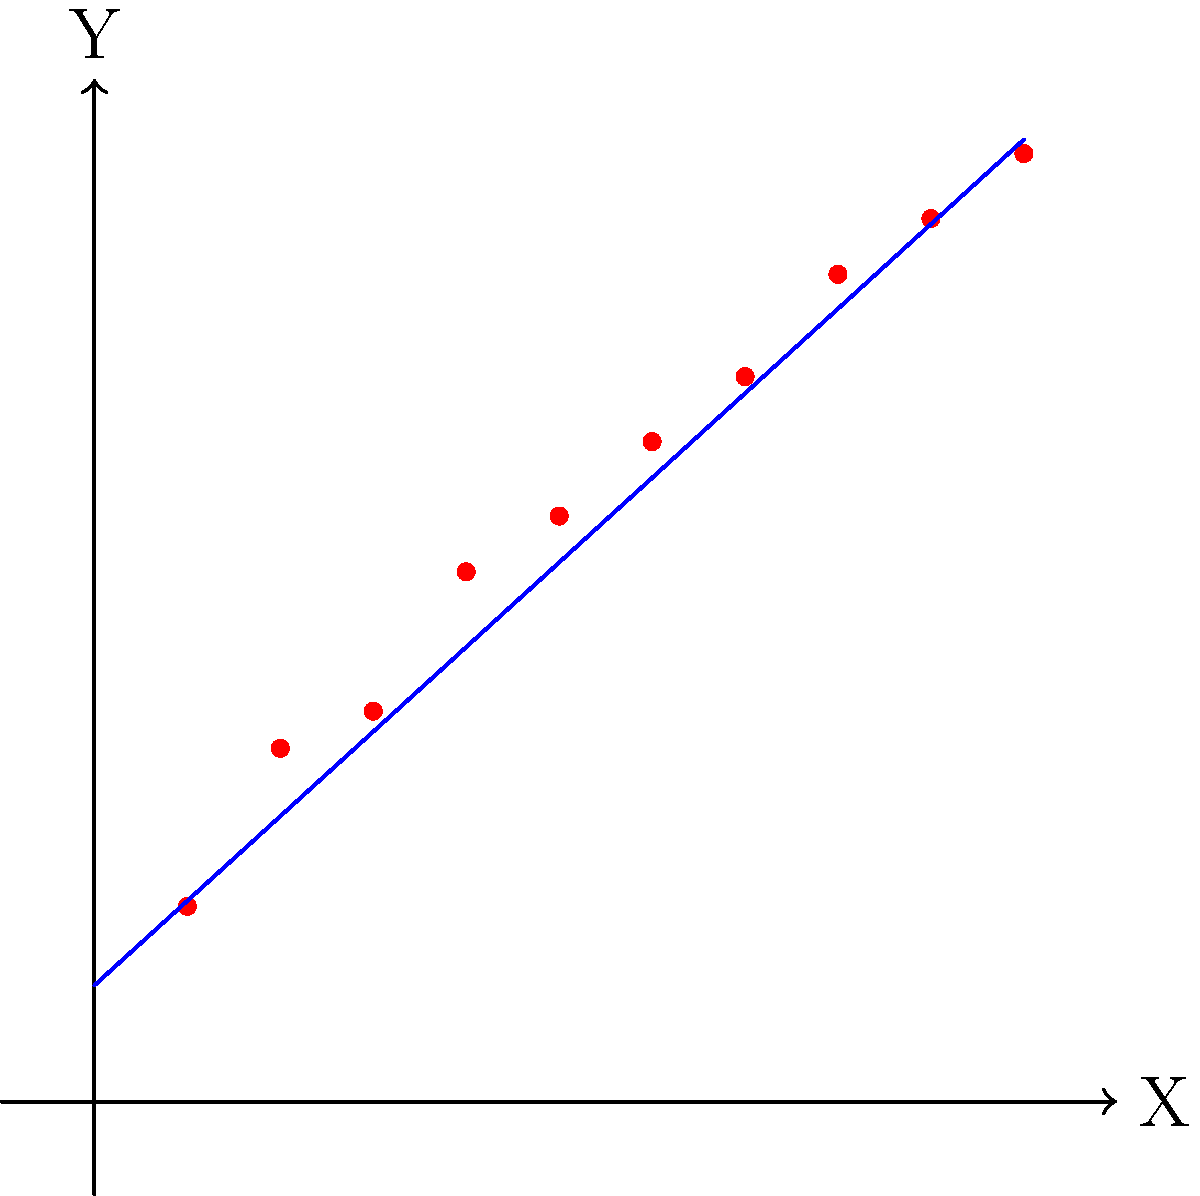In a large-scale study, researchers collected data on two variables, X and Y, from 1000 participants. The scatter plot above shows a representative sample of 10 data points from this study, along with a best-fit line. Based on your analysis of this scatter plot, what can you infer about the correlation between X and Y in the full dataset? Provide your reasoning and discuss any limitations of this inference. To analyze the correlation between X and Y based on the given scatter plot, we can follow these steps:

1. Visual inspection:
   The points appear to follow a clear upward trend from left to right, suggesting a positive correlation.

2. Strength of relationship:
   The points are relatively close to the best-fit line, indicating a strong relationship.

3. Linearity:
   The relationship appears to be approximately linear, as the points don't show any obvious curved pattern.

4. Slope of best-fit line:
   The best-fit line has a positive slope, confirming the positive correlation.

5. Quantitative assessment:
   We can roughly estimate the correlation coefficient (r) to be between 0.8 and 0.95, indicating a strong positive correlation.

6. Inference to full dataset:
   Given that this is a representative sample, we can infer that the full dataset of 1000 participants likely shows a strong positive correlation between X and Y.

7. Limitations:
   a) Sample size: We're basing our inference on only 10 data points, which may not fully represent the variability in the full dataset.
   b) Outliers: The full dataset might contain outliers not present in this sample, which could affect the overall correlation.
   c) Non-linear relationships: If the full dataset has a non-linear relationship, it might not be captured in this small sample.
   d) Confounding variables: There might be other variables influencing the relationship that we can't see from this plot alone.

8. Statistical significance:
   With a larger sample size (n=1000), even a moderate correlation would likely be statistically significant, but we can't determine the exact p-value from this plot.

In conclusion, while we can infer a strong positive correlation in the full dataset, we should be cautious about overgeneralizing from this small sample and consider potential limitations in our inference.
Answer: Strong positive correlation, with caution due to small sample size and potential limitations in representativeness. 